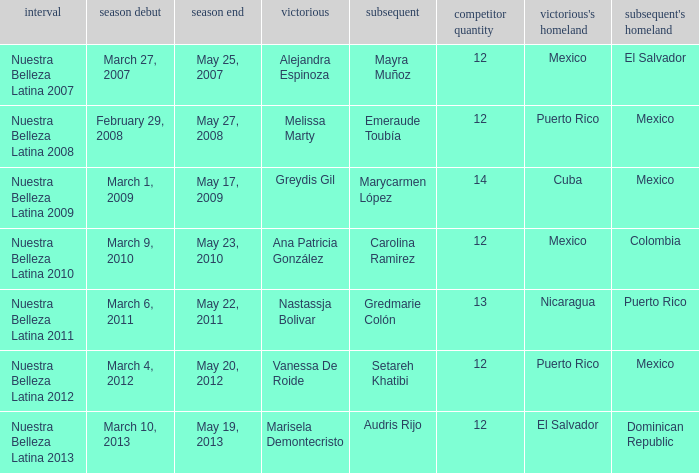What season's premiere had puerto rico winning on May 20, 2012? March 4, 2012. 